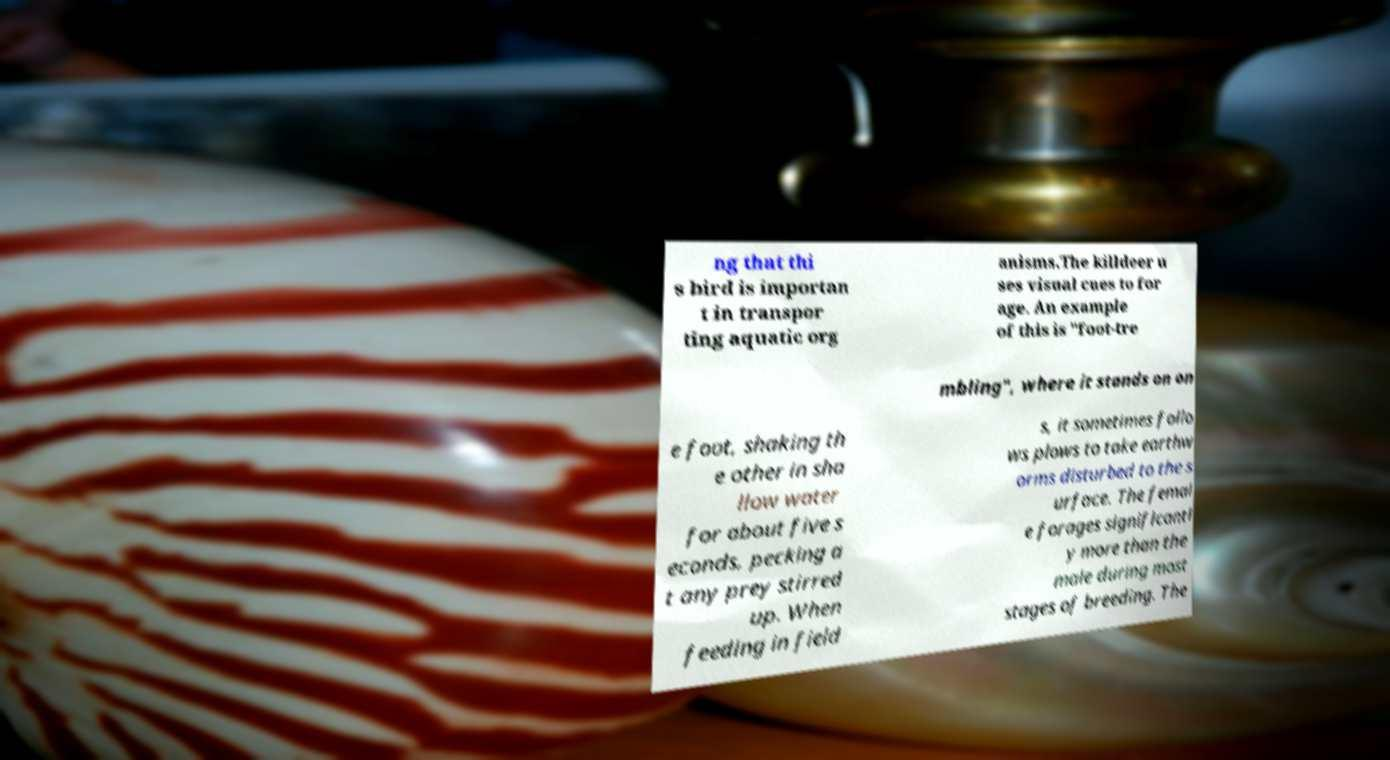Could you extract and type out the text from this image? ng that thi s bird is importan t in transpor ting aquatic org anisms.The killdeer u ses visual cues to for age. An example of this is "foot-tre mbling", where it stands on on e foot, shaking th e other in sha llow water for about five s econds, pecking a t any prey stirred up. When feeding in field s, it sometimes follo ws plows to take earthw orms disturbed to the s urface. The femal e forages significantl y more than the male during most stages of breeding. The 